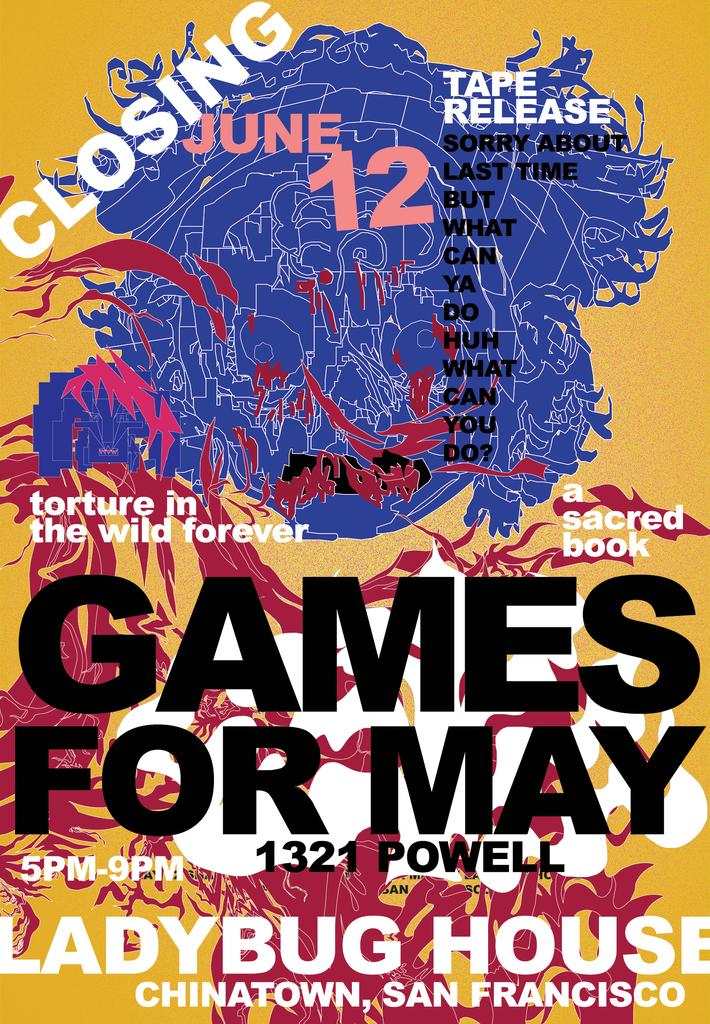<image>
Relay a brief, clear account of the picture shown. An advert for various art mediums at an event called Games for May 